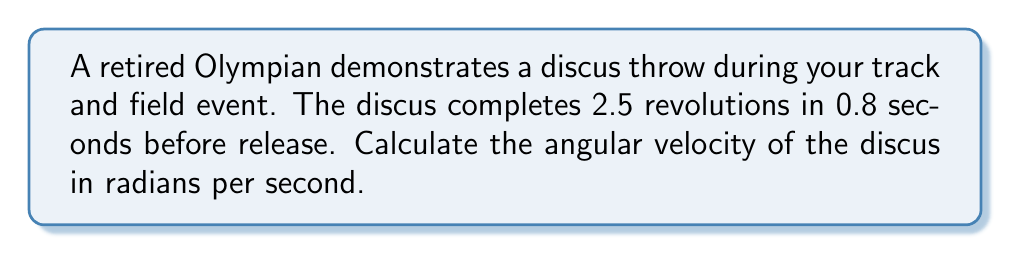Could you help me with this problem? To solve this problem, we'll follow these steps:

1. Understand the given information:
   - The discus completes 2.5 revolutions
   - The time taken is 0.8 seconds

2. Convert revolutions to radians:
   One complete revolution is equal to $2\pi$ radians.
   For 2.5 revolutions: $2.5 \times 2\pi = 5\pi$ radians

3. Calculate the angular velocity:
   Angular velocity ($\omega$) is defined as the angle rotated ($\theta$) divided by the time taken ($t$).

   $$\omega = \frac{\theta}{t}$$

   Where:
   $\theta = 5\pi$ radians
   $t = 0.8$ seconds

   Substituting these values:

   $$\omega = \frac{5\pi}{0.8}$$

4. Simplify the fraction:
   $$\omega = \frac{25\pi}{4}$$

5. Calculate the final value:
   $$\omega \approx 19.63 \text{ rad/s}$$
Answer: $\frac{25\pi}{4}$ rad/s 